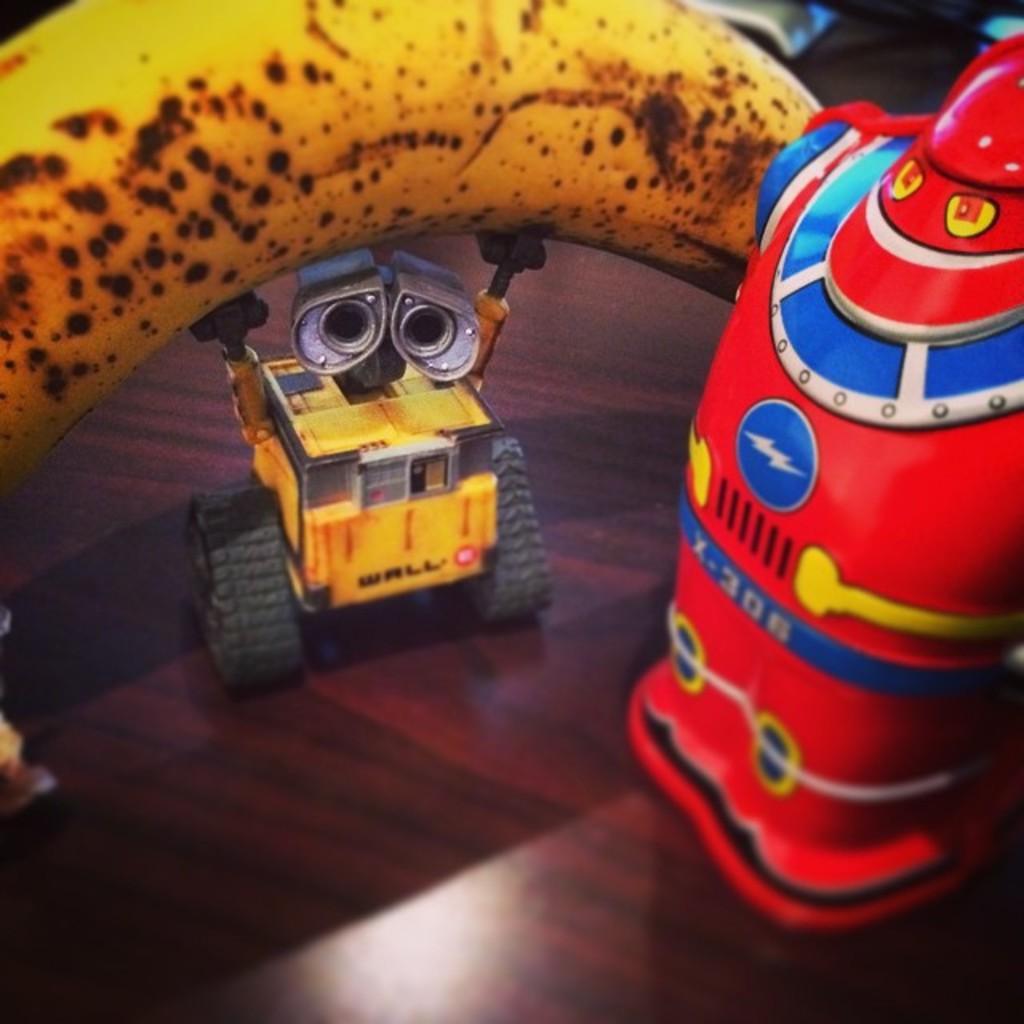Can you describe this image briefly? In the image we can see there are toys, this is a wooden surface and a ripe banana. 